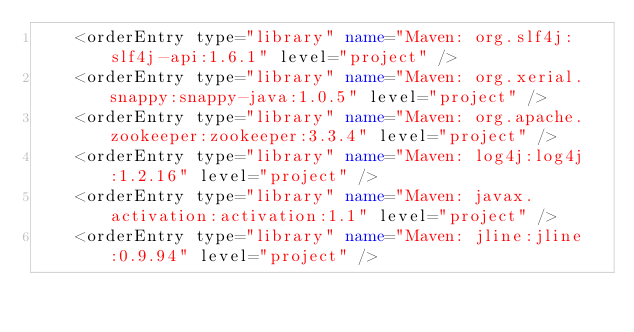Convert code to text. <code><loc_0><loc_0><loc_500><loc_500><_XML_>    <orderEntry type="library" name="Maven: org.slf4j:slf4j-api:1.6.1" level="project" />
    <orderEntry type="library" name="Maven: org.xerial.snappy:snappy-java:1.0.5" level="project" />
    <orderEntry type="library" name="Maven: org.apache.zookeeper:zookeeper:3.3.4" level="project" />
    <orderEntry type="library" name="Maven: log4j:log4j:1.2.16" level="project" />
    <orderEntry type="library" name="Maven: javax.activation:activation:1.1" level="project" />
    <orderEntry type="library" name="Maven: jline:jline:0.9.94" level="project" /></code> 